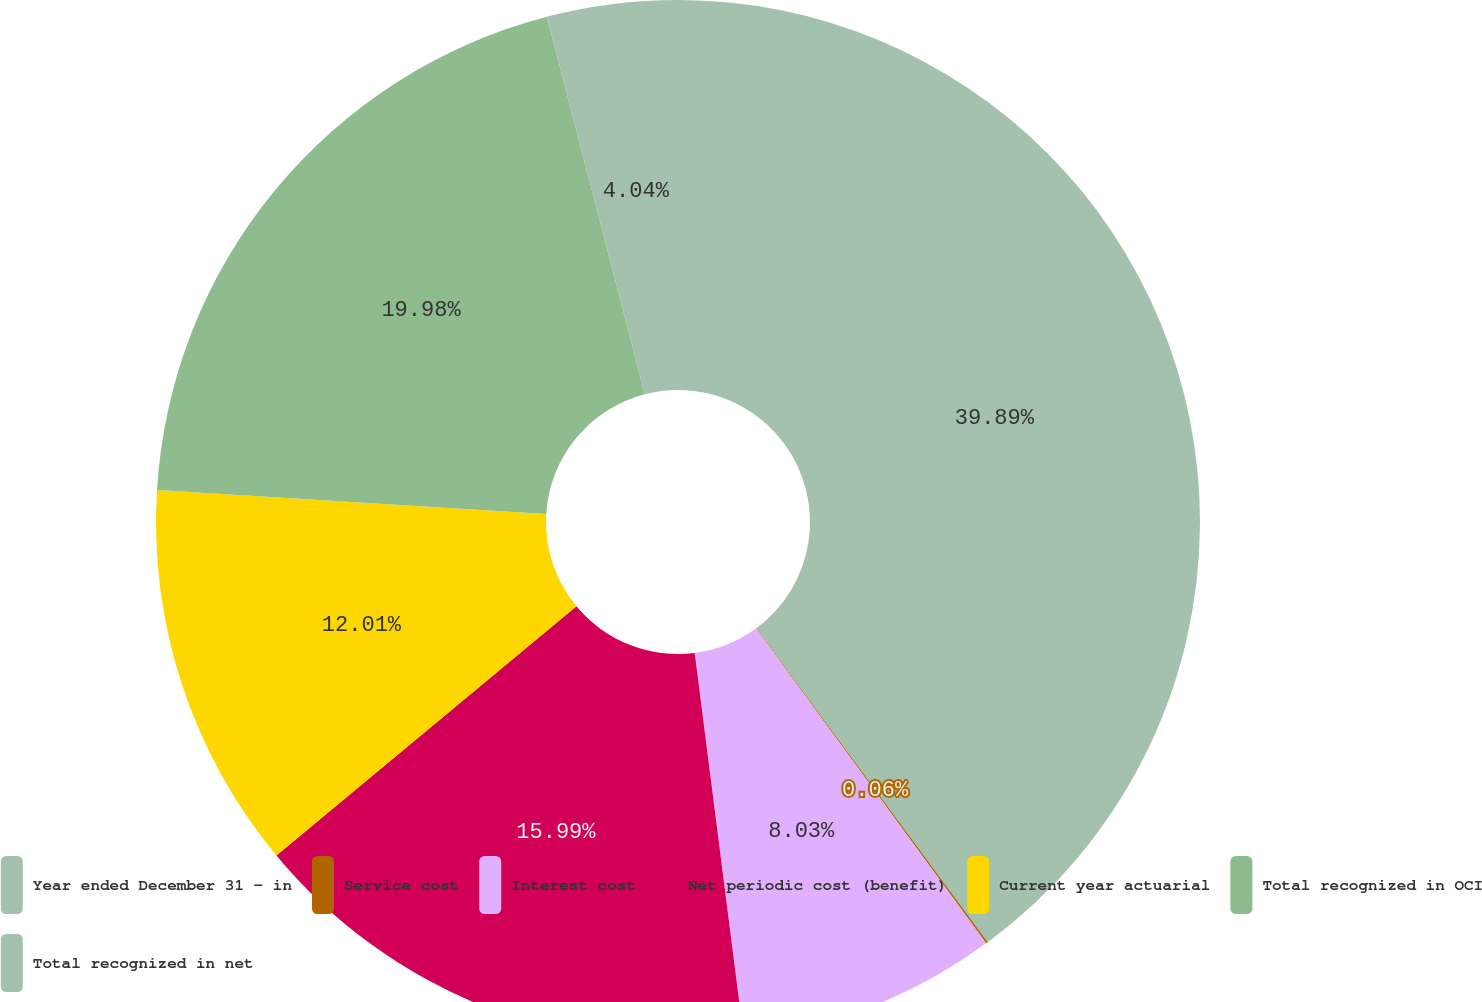Convert chart. <chart><loc_0><loc_0><loc_500><loc_500><pie_chart><fcel>Year ended December 31 - in<fcel>Service cost<fcel>Interest cost<fcel>Net periodic cost (benefit)<fcel>Current year actuarial<fcel>Total recognized in OCI<fcel>Total recognized in net<nl><fcel>39.89%<fcel>0.06%<fcel>8.03%<fcel>15.99%<fcel>12.01%<fcel>19.98%<fcel>4.04%<nl></chart> 